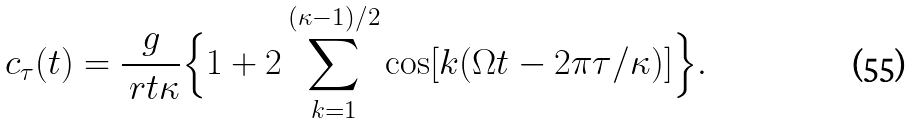<formula> <loc_0><loc_0><loc_500><loc_500>c _ { \tau } ( t ) = \frac { g } { \ r t { \kappa } } \Big { \{ } 1 + 2 \sum _ { k = 1 } ^ { ( \kappa - 1 ) / 2 } \cos [ k ( \Omega t - 2 \pi \tau / \kappa ) ] \Big { \} } .</formula> 